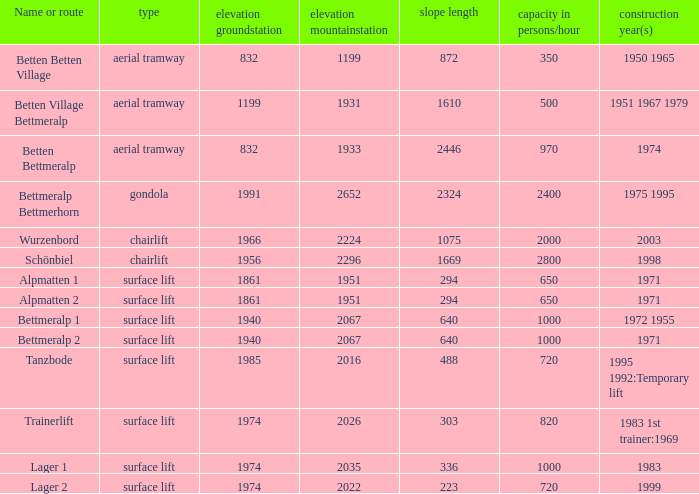Which elevation groundstation has a capacity in persons/hour larger than 820, and a Name or route of lager 1, and a slope length smaller than 336? None. 